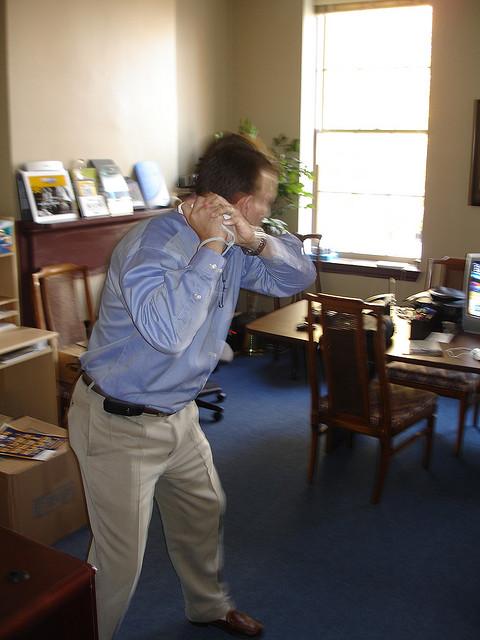What color is the man's shirt?
Write a very short answer. Blue. What kind of room is this?
Concise answer only. Dining room. What is the man doing?
Give a very brief answer. Playing wii. 